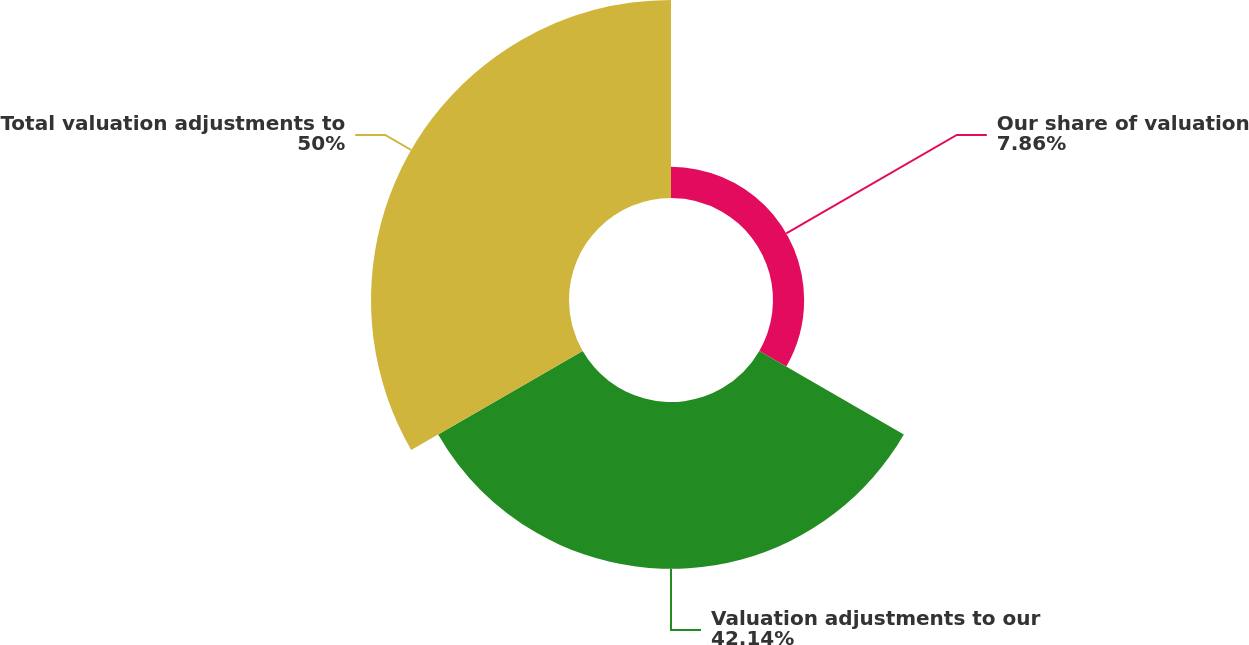Convert chart. <chart><loc_0><loc_0><loc_500><loc_500><pie_chart><fcel>Our share of valuation<fcel>Valuation adjustments to our<fcel>Total valuation adjustments to<nl><fcel>7.86%<fcel>42.14%<fcel>50.0%<nl></chart> 